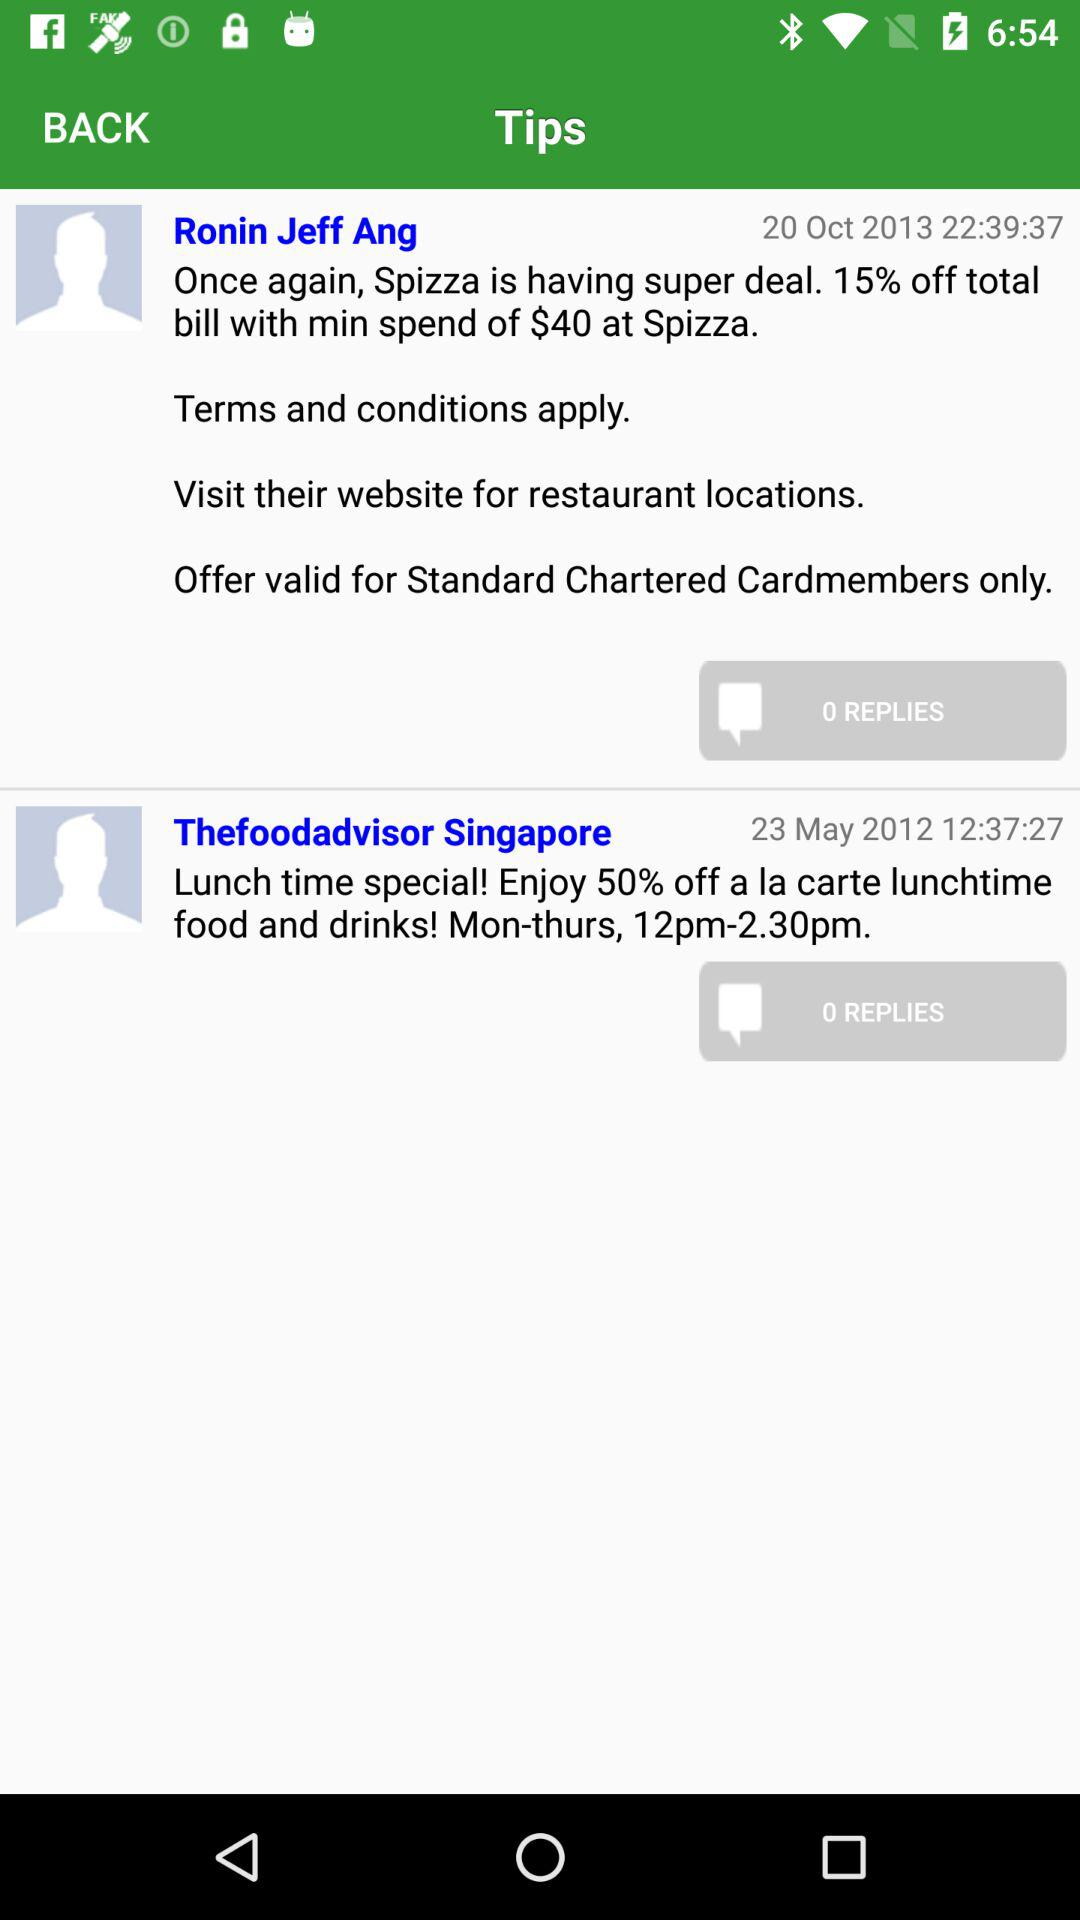At what time was the message posted by Ronin Jeff Ang? The message was posted at 22:39:37. 